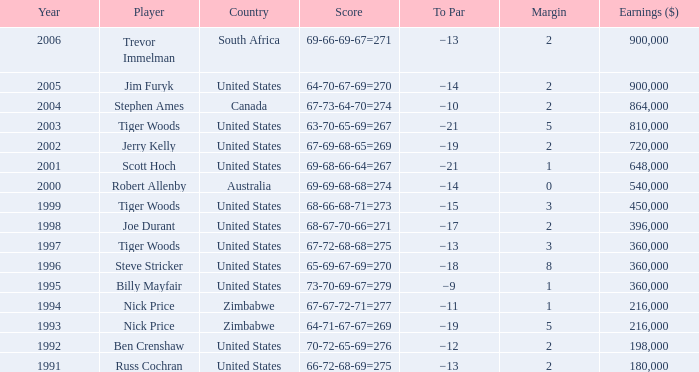What is canada's margin? 2.0. 